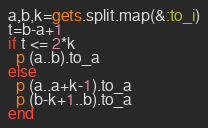Convert code to text. <code><loc_0><loc_0><loc_500><loc_500><_Ruby_>a,b,k=gets.split.map(&:to_i)
t=b-a+1
if t <= 2*k
  p (a..b).to_a
else
  p (a..a+k-1).to_a
  p (b-k+1..b).to_a
end</code> 